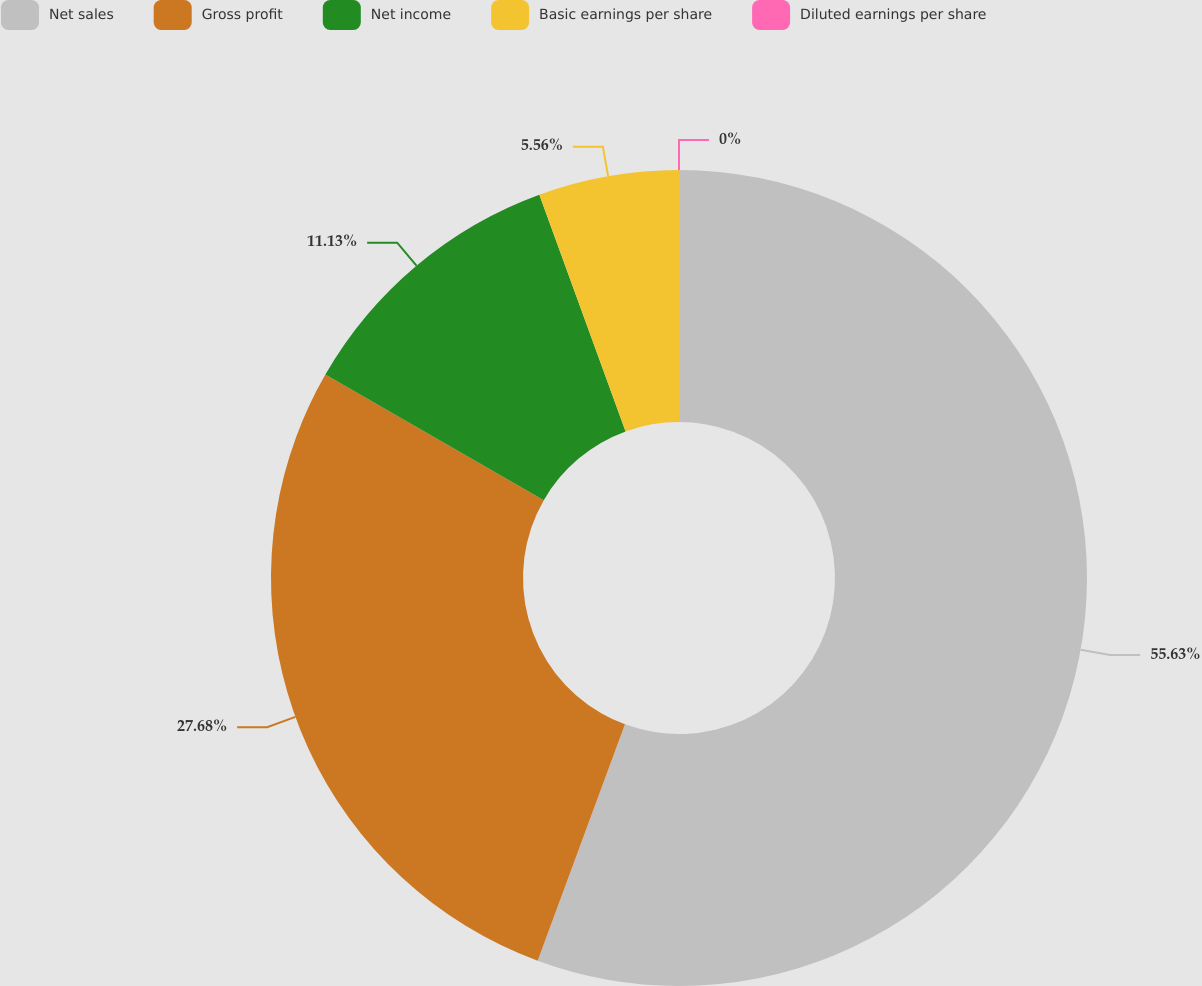Convert chart. <chart><loc_0><loc_0><loc_500><loc_500><pie_chart><fcel>Net sales<fcel>Gross profit<fcel>Net income<fcel>Basic earnings per share<fcel>Diluted earnings per share<nl><fcel>55.63%<fcel>27.68%<fcel>11.13%<fcel>5.56%<fcel>0.0%<nl></chart> 